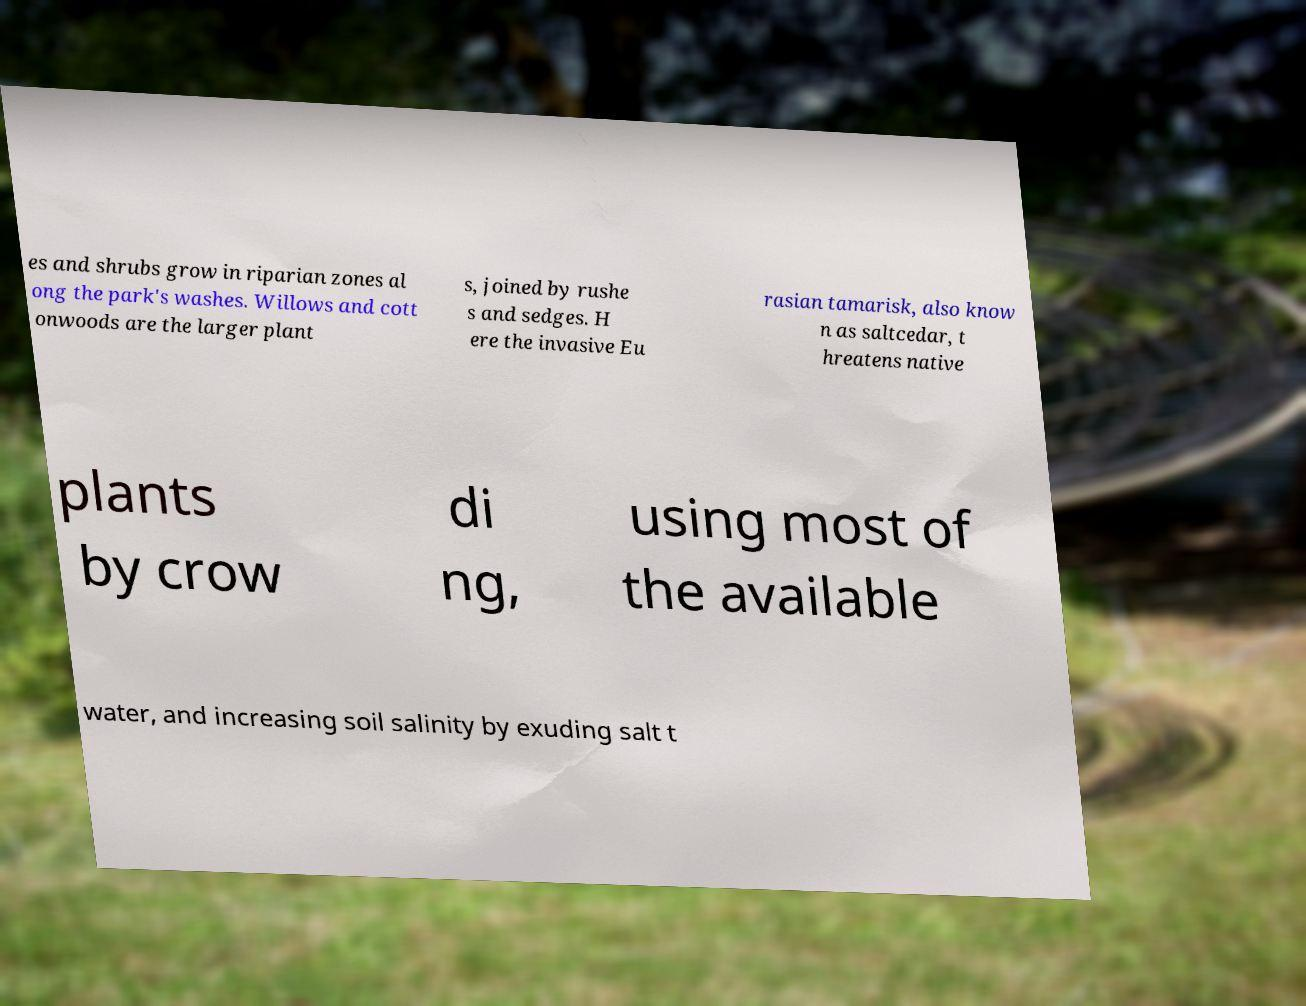Can you accurately transcribe the text from the provided image for me? es and shrubs grow in riparian zones al ong the park's washes. Willows and cott onwoods are the larger plant s, joined by rushe s and sedges. H ere the invasive Eu rasian tamarisk, also know n as saltcedar, t hreatens native plants by crow di ng, using most of the available water, and increasing soil salinity by exuding salt t 